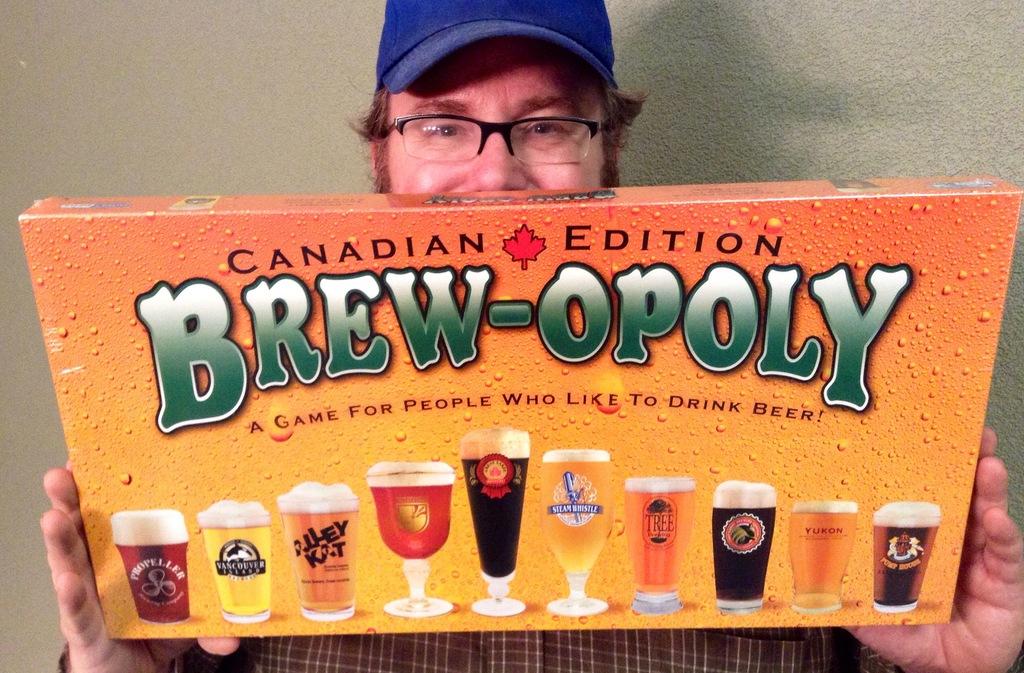What is the name of this game?
Offer a terse response. Brew-opoly. Which edition of brew-opoly is this?
Your response must be concise. Canadian. 